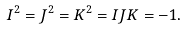<formula> <loc_0><loc_0><loc_500><loc_500>I ^ { 2 } = J ^ { 2 } = K ^ { 2 } = I J K = - 1 .</formula> 